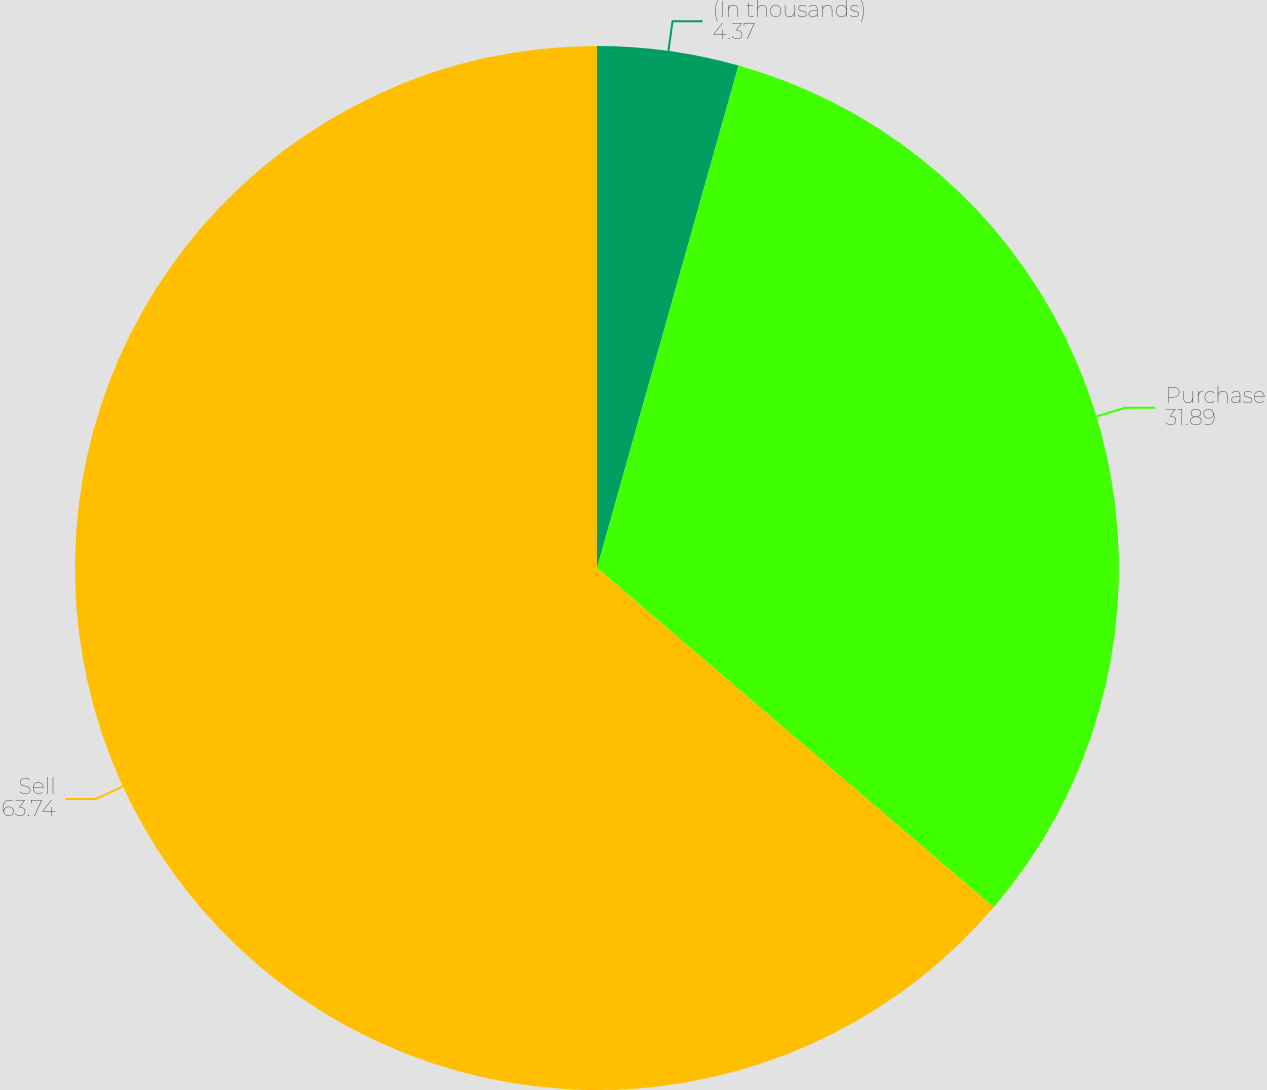Convert chart to OTSL. <chart><loc_0><loc_0><loc_500><loc_500><pie_chart><fcel>(In thousands)<fcel>Purchase<fcel>Sell<nl><fcel>4.37%<fcel>31.89%<fcel>63.74%<nl></chart> 